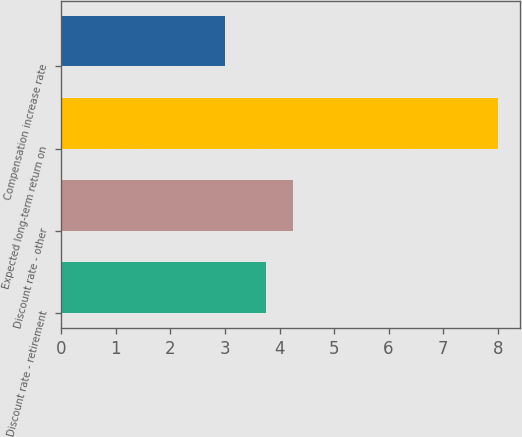Convert chart to OTSL. <chart><loc_0><loc_0><loc_500><loc_500><bar_chart><fcel>Discount rate - retirement<fcel>Discount rate - other<fcel>Expected long-term return on<fcel>Compensation increase rate<nl><fcel>3.75<fcel>4.25<fcel>8<fcel>3<nl></chart> 